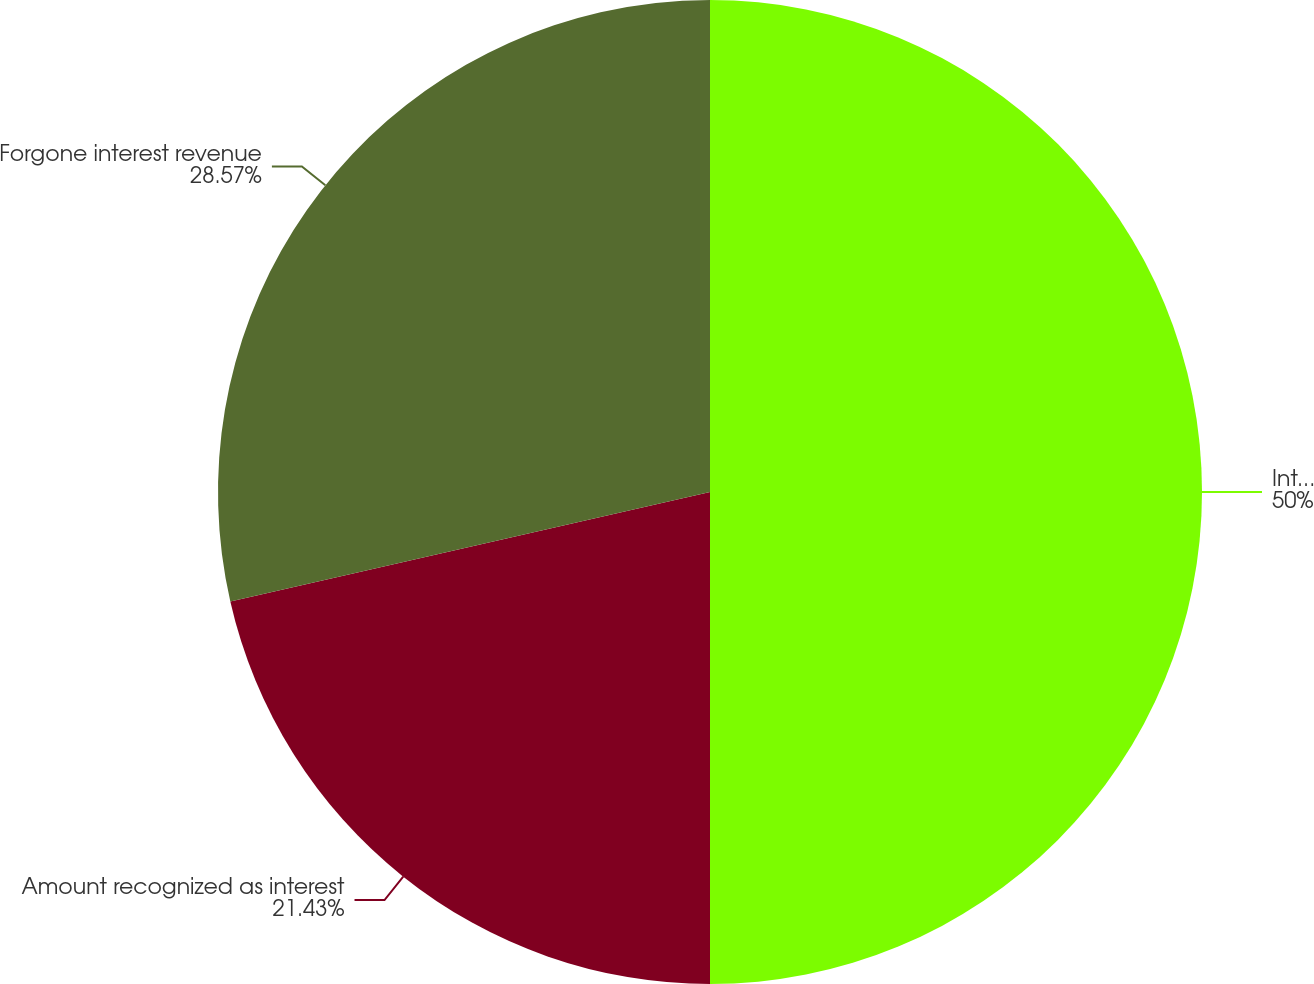Convert chart. <chart><loc_0><loc_0><loc_500><loc_500><pie_chart><fcel>Interest revenue that would<fcel>Amount recognized as interest<fcel>Forgone interest revenue<nl><fcel>50.0%<fcel>21.43%<fcel>28.57%<nl></chart> 